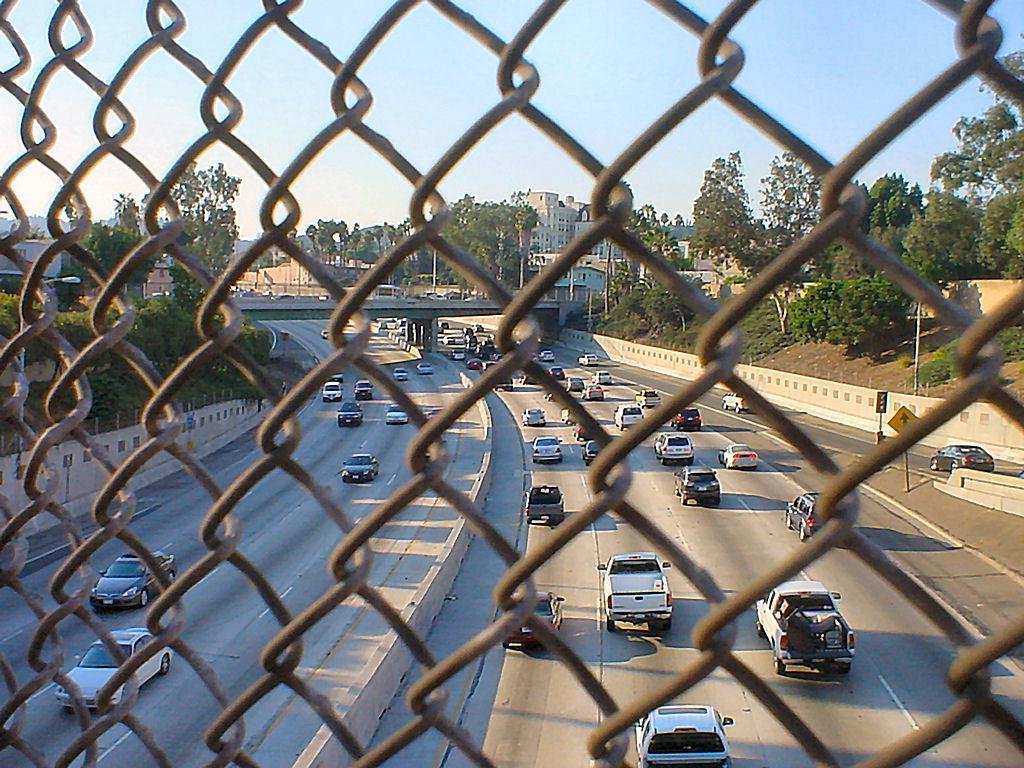Please provide a concise description of this image. In the foreground of the picture I can see the metal grill fence. I can see the vehicles on the road. In the background, I can see the bridge construction and buildings. There are trees on the left side and the right side as well. There are clouds in the sky. 